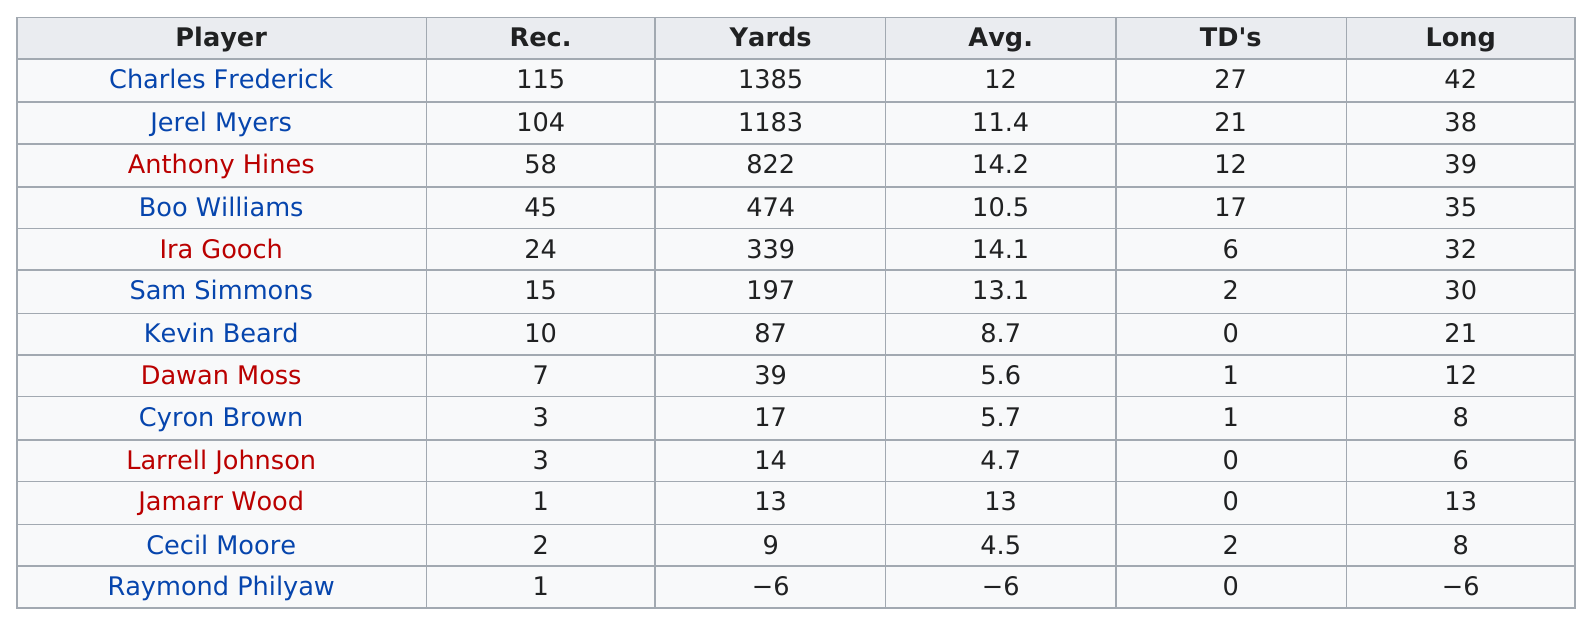Draw attention to some important aspects in this diagram. Anthony Hines and Boo Williams have combined for a total of 29 touchdowns. The next player after Charles Frederick to receive the most yards in 2007 was Jerel Myers. The individual who accumulated the most yards is Charles Frederick. The players named Kevin Beard, Larrell Johnson, Jamarr Wood, and Raymond Philyaw did not score any touchdowns. Charles Frederick has the most touchdowns among all players. 